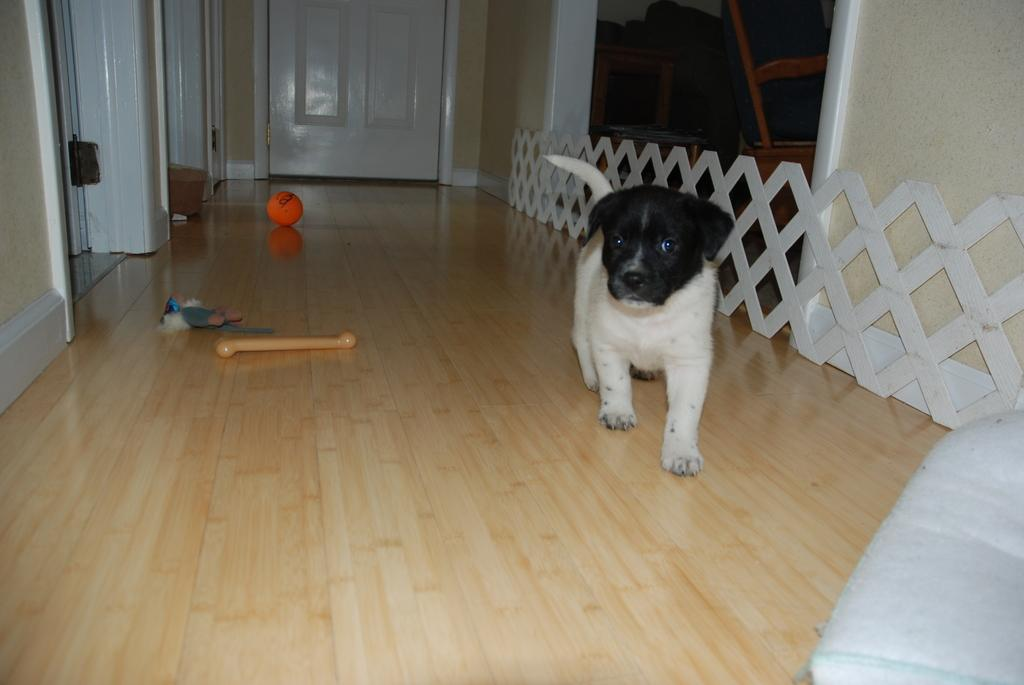What type of animal is present in the image? There is a puppy in the image. What object can be seen near the puppy? There is a ball in the image. What architectural feature is visible in the background of the image? There is a door in the background of the image. What type of flooring is present at the bottom of the image? There is wooden flooring at the bottom of the image. What type of egg is the puppy holding in the image? There is no egg present in the image; the puppy is not holding anything. 